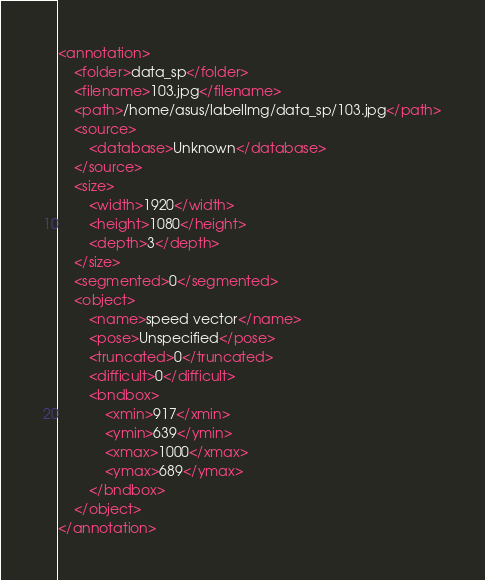<code> <loc_0><loc_0><loc_500><loc_500><_XML_><annotation>
	<folder>data_sp</folder>
	<filename>103.jpg</filename>
	<path>/home/asus/labelImg/data_sp/103.jpg</path>
	<source>
		<database>Unknown</database>
	</source>
	<size>
		<width>1920</width>
		<height>1080</height>
		<depth>3</depth>
	</size>
	<segmented>0</segmented>
	<object>
		<name>speed vector</name>
		<pose>Unspecified</pose>
		<truncated>0</truncated>
		<difficult>0</difficult>
		<bndbox>
			<xmin>917</xmin>
			<ymin>639</ymin>
			<xmax>1000</xmax>
			<ymax>689</ymax>
		</bndbox>
	</object>
</annotation>
</code> 